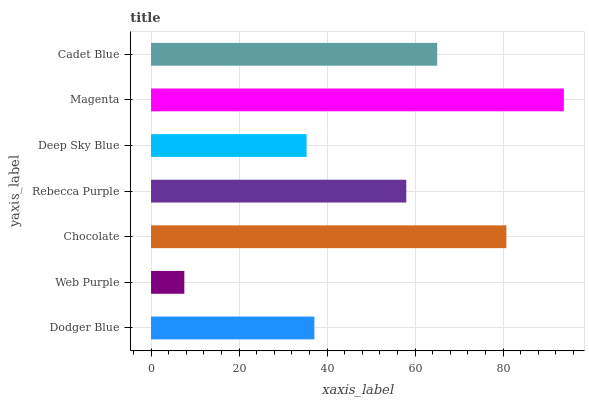Is Web Purple the minimum?
Answer yes or no. Yes. Is Magenta the maximum?
Answer yes or no. Yes. Is Chocolate the minimum?
Answer yes or no. No. Is Chocolate the maximum?
Answer yes or no. No. Is Chocolate greater than Web Purple?
Answer yes or no. Yes. Is Web Purple less than Chocolate?
Answer yes or no. Yes. Is Web Purple greater than Chocolate?
Answer yes or no. No. Is Chocolate less than Web Purple?
Answer yes or no. No. Is Rebecca Purple the high median?
Answer yes or no. Yes. Is Rebecca Purple the low median?
Answer yes or no. Yes. Is Magenta the high median?
Answer yes or no. No. Is Cadet Blue the low median?
Answer yes or no. No. 